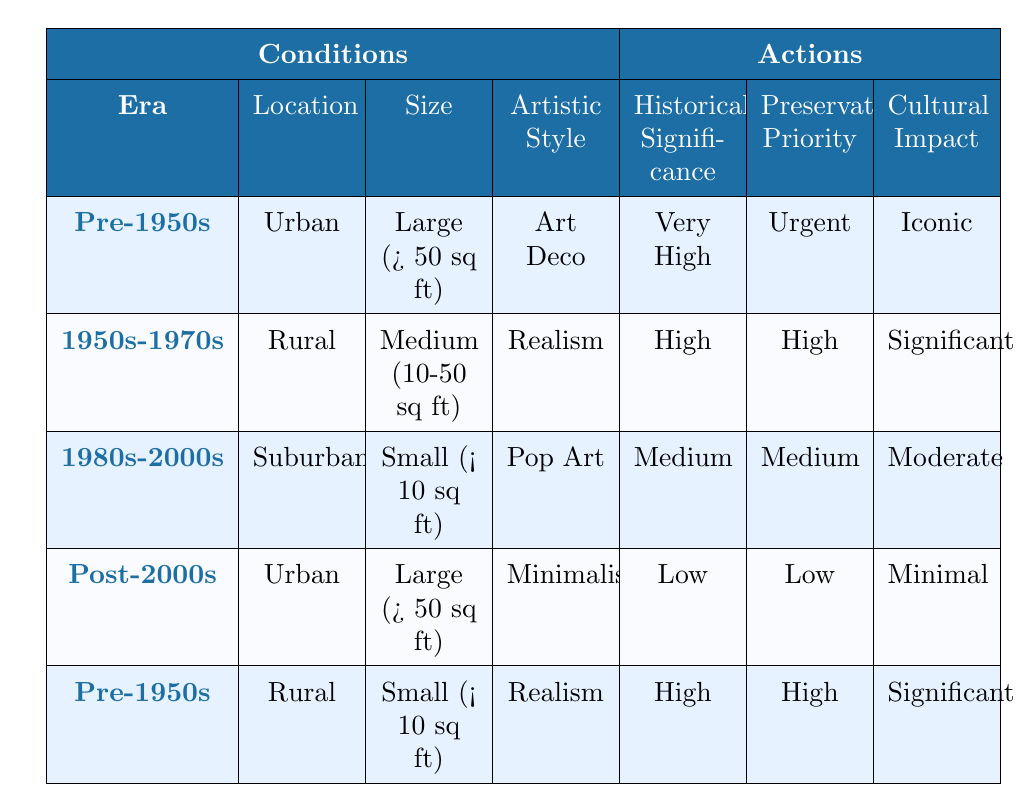What is the preservation priority for hand-painted advertisements from the 1980s to 2000s that are small in size and in a suburban location with a Pop Art style? According to the table, the preservation priority for this specific combination is "Medium." The relevant row shows that for advertisements from the 1980s to 2000s, located in suburban areas, size classified as small, with the artistic style being Pop Art, the corresponding preservation priority is listed as Medium.
Answer: Medium What is the historical significance of hand-painted advertisements from the Pre-1950s era that are large in size, located in urban areas, and follow the Art Deco style? The table indicates that for Pre-1950s advertisements that are large, located in urban areas, and follow the Art Deco style, the historical significance is "Very High." This is confirmed by directly referencing the corresponding row in the table.
Answer: Very High Is there a significant cultural impact for hand-painted advertisements from the 1950s to 1970s located in rural areas that are medium in size and designed with realism? Yes, the table states that the cultural impact for this category is "Significant." Looking at the row that corresponds to this specific combination verifies its status as significant.
Answer: Yes How many styles have a "High" preservation priority? From the table, two rows indicate a preservation priority of "High." The first one is for the 1950s-1970s in rural areas with medium size and realism style, and the second is for Pre-1950s rural and small size with realism style. Therefore, the total number of styles is two.
Answer: 2 What is the cultural impact of hand-painted advertisements from the Post-2000s era that are large and follow the Minimalism style? The table reveals that for Post-2000s advertisements, large in size and of the Minimalism style, the cultural impact is "Minimal." This can be determined by checking the respective row in the table.
Answer: Minimal What is the average historical significance rating for all hand-painted advertisements listed in the table? The historical significance ratings in the table are Very High, High, Medium, Low, and High for the respective styles. Assign a numerical value: Very High (4), High (3), Medium (2), Low (1). The calculations are: (4 + 3 + 2 + 1 + 3) = 13. The average is then 13 divided by 5 (the total number of entries), which equals 2.6, rounding to approximately Medium.
Answer: Medium Are there any advertisements from the 1980s to 2000s that have a "High" historical significance? No, the table shows that the highest historical significance for advertisements from the 1980s to 2000s is rated as "Medium." Upon reviewing all relevant rows for this era, none meet the criteria of "High."
Answer: No 